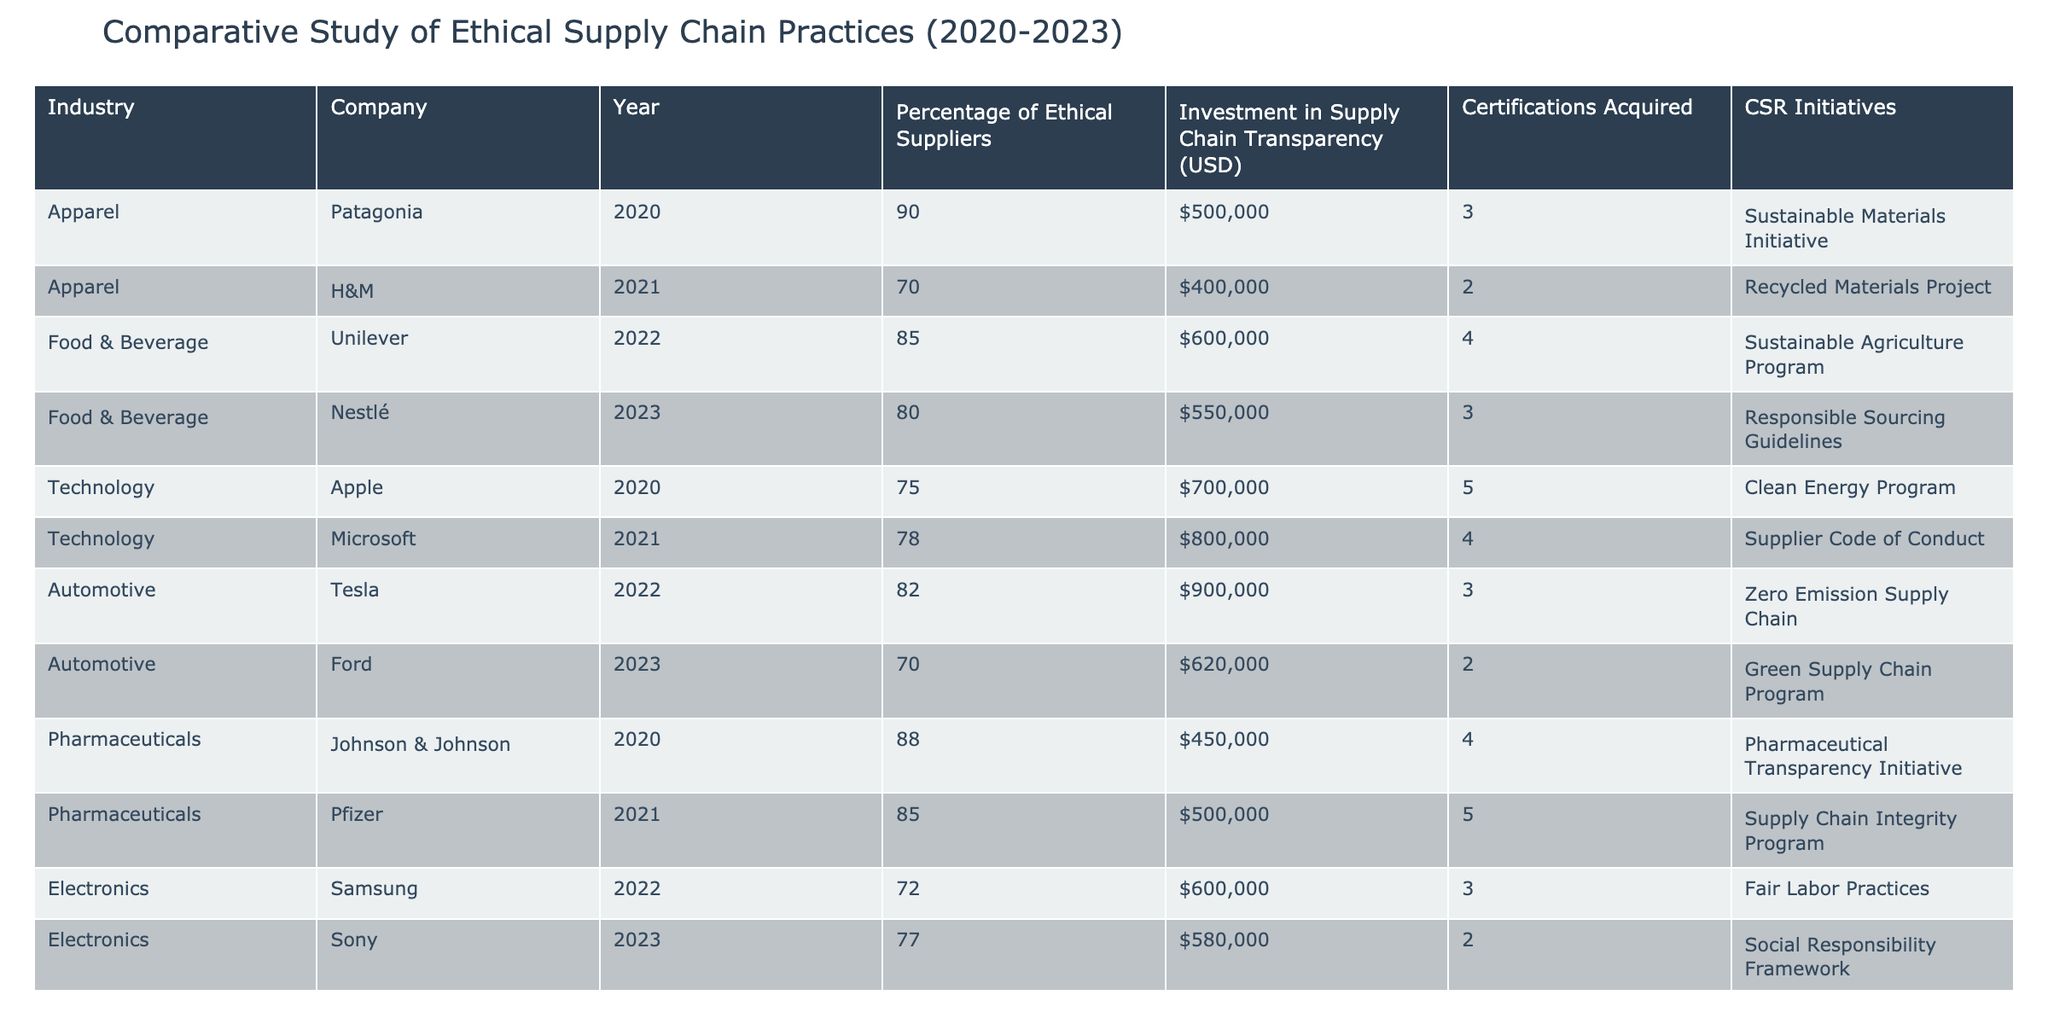What was the highest percentage of ethical suppliers recorded during the study? Looking through the table, Patagonia in 2020 has the highest recorded percentage of ethical suppliers at 90%.
Answer: 90% What investment did Unilever make in supply chain transparency in 2022? According to the table, Unilever made an investment of $600,000 in supply chain transparency in 2022.
Answer: $600,000 What is the average percentage of ethical suppliers across the technology industry from 2020 to 2023? The percentages of ethical suppliers in the technology industry are 75% (Apple), 78% (Microsoft), and 77% (Sony). The average is calculated as (75 + 78 + 77) / 3 = 76.67%.
Answer: 76.67% Did Ford acquire more or fewer certifications than Tesla in 2023? Ford acquired 2 certifications, while Tesla acquired 3 certifications in 2022. Therefore, Ford acquired fewer certifications than Tesla.
Answer: Fewer Which company had the highest investment in supply chain transparency, and how much was it? In the table, Tesla invested $900,000 in supply chain transparency in 2022, which is the highest investment among the listed companies.
Answer: $900,000 What is the difference in the percentage of ethical suppliers between Johnson & Johnson (2020) and Pfizer (2021)? Johnson & Johnson had 88% of ethical suppliers, while Pfizer had 85%. The difference is calculated as 88% - 85% = 3%.
Answer: 3% Which industry had the most companies listed in the study? By examining the table, both the apparel and food & beverage industries have two companies listed, while technology, automotive, and pharmaceuticals have only one each. Thus, the apparel and food & beverage industries had the most companies listed, with a total of 2 each.
Answer: Apparel and Food & Beverage What percentage of ethical suppliers does H&M have compared to Nestlé? H&M has 70% of ethical suppliers in 2021, while Nestlé has 80% in 2023. Thus, Nestlé has a higher percentage of ethical suppliers compared to H&M.
Answer: Nestlé has a higher percentage 